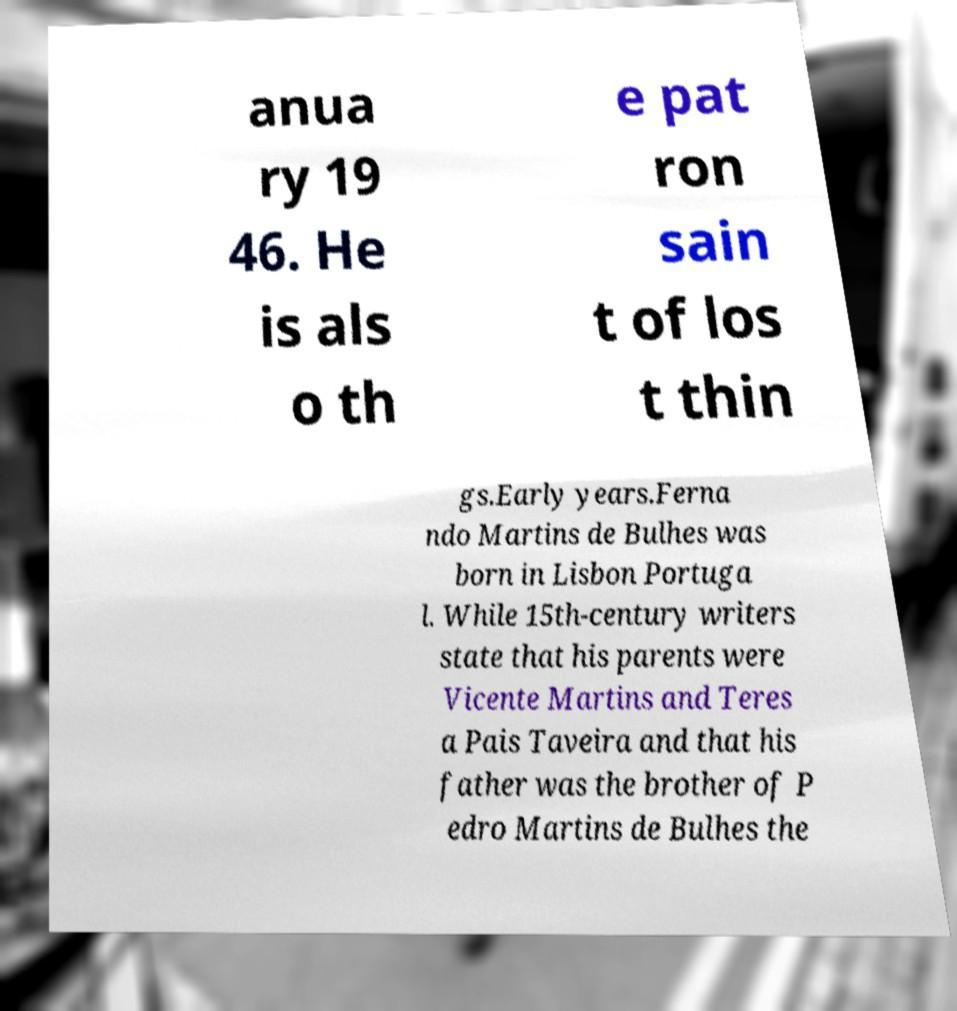There's text embedded in this image that I need extracted. Can you transcribe it verbatim? anua ry 19 46. He is als o th e pat ron sain t of los t thin gs.Early years.Ferna ndo Martins de Bulhes was born in Lisbon Portuga l. While 15th-century writers state that his parents were Vicente Martins and Teres a Pais Taveira and that his father was the brother of P edro Martins de Bulhes the 